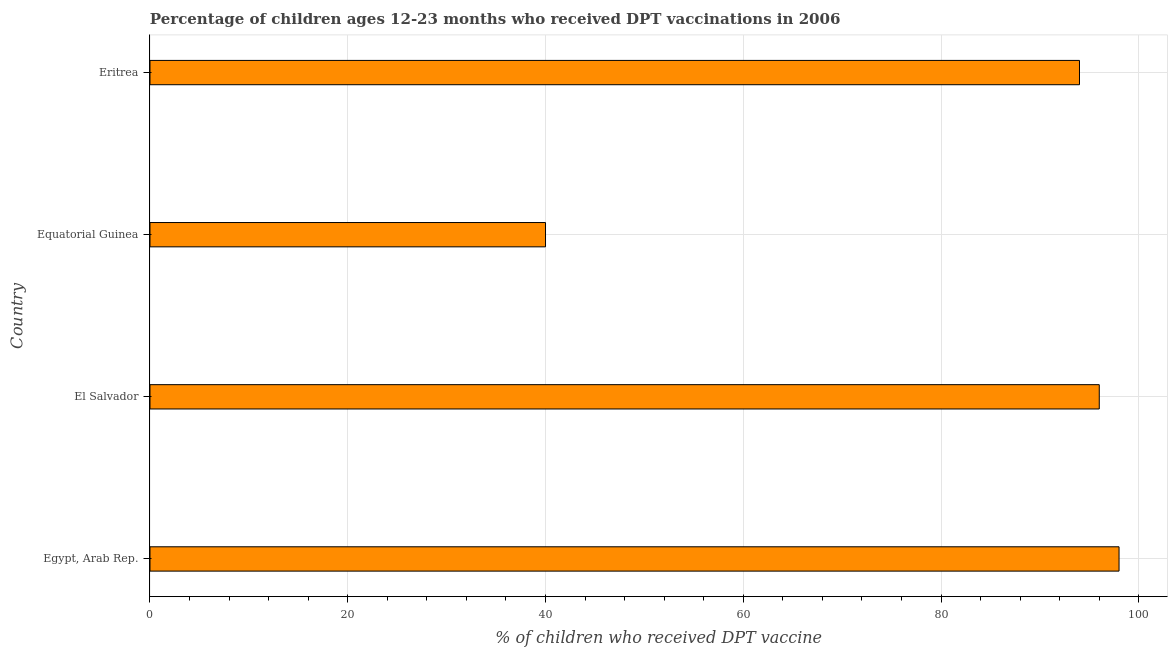What is the title of the graph?
Keep it short and to the point. Percentage of children ages 12-23 months who received DPT vaccinations in 2006. What is the label or title of the X-axis?
Offer a terse response. % of children who received DPT vaccine. What is the label or title of the Y-axis?
Provide a succinct answer. Country. Across all countries, what is the maximum percentage of children who received dpt vaccine?
Your response must be concise. 98. In which country was the percentage of children who received dpt vaccine maximum?
Offer a terse response. Egypt, Arab Rep. In which country was the percentage of children who received dpt vaccine minimum?
Provide a succinct answer. Equatorial Guinea. What is the sum of the percentage of children who received dpt vaccine?
Give a very brief answer. 328. What is the difference between the percentage of children who received dpt vaccine in Egypt, Arab Rep. and Eritrea?
Give a very brief answer. 4. What is the average percentage of children who received dpt vaccine per country?
Ensure brevity in your answer.  82. In how many countries, is the percentage of children who received dpt vaccine greater than 80 %?
Keep it short and to the point. 3. Is the percentage of children who received dpt vaccine in Egypt, Arab Rep. less than that in Equatorial Guinea?
Your answer should be very brief. No. Is the difference between the percentage of children who received dpt vaccine in El Salvador and Equatorial Guinea greater than the difference between any two countries?
Make the answer very short. No. What is the difference between the highest and the second highest percentage of children who received dpt vaccine?
Your answer should be very brief. 2. In how many countries, is the percentage of children who received dpt vaccine greater than the average percentage of children who received dpt vaccine taken over all countries?
Offer a very short reply. 3. How many bars are there?
Offer a terse response. 4. Are the values on the major ticks of X-axis written in scientific E-notation?
Your answer should be compact. No. What is the % of children who received DPT vaccine of Egypt, Arab Rep.?
Make the answer very short. 98. What is the % of children who received DPT vaccine in El Salvador?
Give a very brief answer. 96. What is the % of children who received DPT vaccine in Equatorial Guinea?
Your response must be concise. 40. What is the % of children who received DPT vaccine of Eritrea?
Provide a succinct answer. 94. What is the difference between the % of children who received DPT vaccine in Egypt, Arab Rep. and El Salvador?
Your answer should be very brief. 2. What is the difference between the % of children who received DPT vaccine in Egypt, Arab Rep. and Equatorial Guinea?
Your answer should be compact. 58. What is the difference between the % of children who received DPT vaccine in Egypt, Arab Rep. and Eritrea?
Offer a very short reply. 4. What is the difference between the % of children who received DPT vaccine in El Salvador and Eritrea?
Offer a very short reply. 2. What is the difference between the % of children who received DPT vaccine in Equatorial Guinea and Eritrea?
Ensure brevity in your answer.  -54. What is the ratio of the % of children who received DPT vaccine in Egypt, Arab Rep. to that in El Salvador?
Ensure brevity in your answer.  1.02. What is the ratio of the % of children who received DPT vaccine in Egypt, Arab Rep. to that in Equatorial Guinea?
Offer a terse response. 2.45. What is the ratio of the % of children who received DPT vaccine in Egypt, Arab Rep. to that in Eritrea?
Your answer should be very brief. 1.04. What is the ratio of the % of children who received DPT vaccine in El Salvador to that in Equatorial Guinea?
Provide a short and direct response. 2.4. What is the ratio of the % of children who received DPT vaccine in Equatorial Guinea to that in Eritrea?
Offer a terse response. 0.43. 